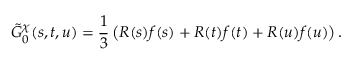<formula> <loc_0><loc_0><loc_500><loc_500>\tilde { G } _ { 0 } ^ { \chi } ( s , t , u ) = { \frac { 1 } { 3 } } \left ( R ( s ) f ( s ) + R ( t ) f ( t ) + R ( u ) f ( u ) \right ) .</formula> 